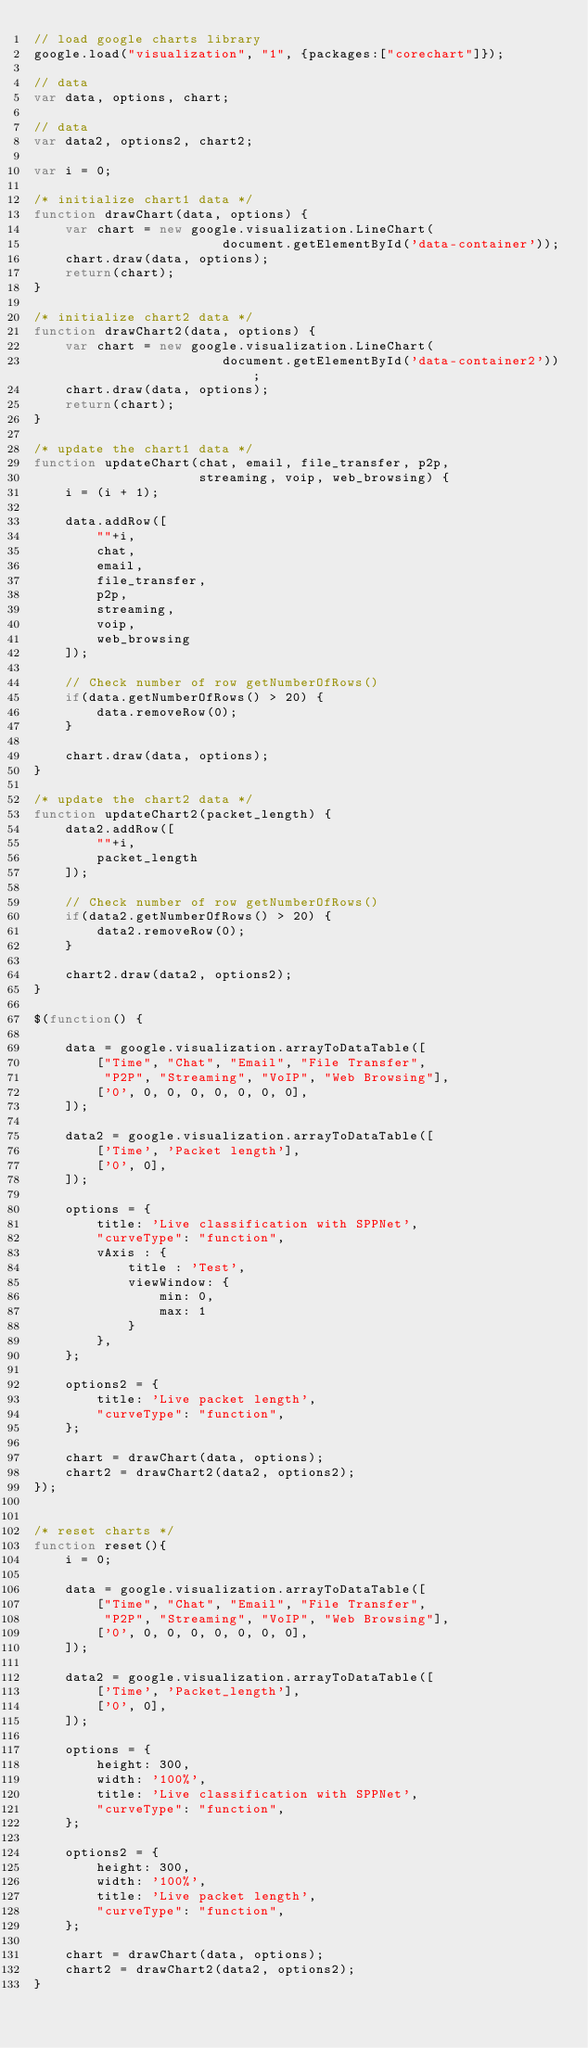<code> <loc_0><loc_0><loc_500><loc_500><_JavaScript_>// load google charts library
google.load("visualization", "1", {packages:["corechart"]});

// data
var data, options, chart;

// data
var data2, options2, chart2;

var i = 0;

/* initialize chart1 data */
function drawChart(data, options) {
    var chart = new google.visualization.LineChart(
                        document.getElementById('data-container'));
    chart.draw(data, options);
    return(chart);
}

/* initialize chart2 data */
function drawChart2(data, options) {
    var chart = new google.visualization.LineChart(
                        document.getElementById('data-container2'));
    chart.draw(data, options);
    return(chart);
}

/* update the chart1 data */
function updateChart(chat, email, file_transfer, p2p, 
                     streaming, voip, web_browsing) {
    i = (i + 1);

    data.addRow([
        ""+i,
        chat, 
        email,
        file_transfer, 
        p2p,
        streaming,
        voip,
        web_browsing
    ]);

    // Check number of row getNumberOfRows()
    if(data.getNumberOfRows() > 20) {
        data.removeRow(0);
    }

    chart.draw(data, options);
}

/* update the chart2 data */
function updateChart2(packet_length) {
    data2.addRow([
        ""+i,
        packet_length
    ]);

    // Check number of row getNumberOfRows()
    if(data2.getNumberOfRows() > 20) {
        data2.removeRow(0);
    }

    chart2.draw(data2, options2);
}

$(function() {

    data = google.visualization.arrayToDataTable([
        ["Time", "Chat", "Email", "File Transfer", 
         "P2P", "Streaming", "VoIP", "Web Browsing"],
        ['0', 0, 0, 0, 0, 0, 0, 0],
    ]);

    data2 = google.visualization.arrayToDataTable([
        ['Time', 'Packet length'],
        ['0', 0],
    ]);
    
    options = {
        title: 'Live classification with SPPNet',
        "curveType": "function",
        vAxis : {
            title : 'Test',
            viewWindow: {
                min: 0,
                max: 1
            }
        },
    };

    options2 = {
        title: 'Live packet length',
        "curveType": "function",
    };

    chart = drawChart(data, options);
    chart2 = drawChart2(data2, options2);
});


/* reset charts */
function reset(){
    i = 0;
    
    data = google.visualization.arrayToDataTable([
        ["Time", "Chat", "Email", "File Transfer", 
         "P2P", "Streaming", "VoIP", "Web Browsing"],
        ['0', 0, 0, 0, 0, 0, 0, 0],
    ]);

    data2 = google.visualization.arrayToDataTable([
        ['Time', 'Packet_length'],
        ['0', 0],
    ]);

    options = {
        height: 300,
        width: '100%',
        title: 'Live classification with SPPNet',
        "curveType": "function",
    };

    options2 = {
        height: 300,
        width: '100%',
        title: 'Live packet length',
        "curveType": "function",
    };

    chart = drawChart(data, options);
    chart2 = drawChart2(data2, options2);
}
</code> 